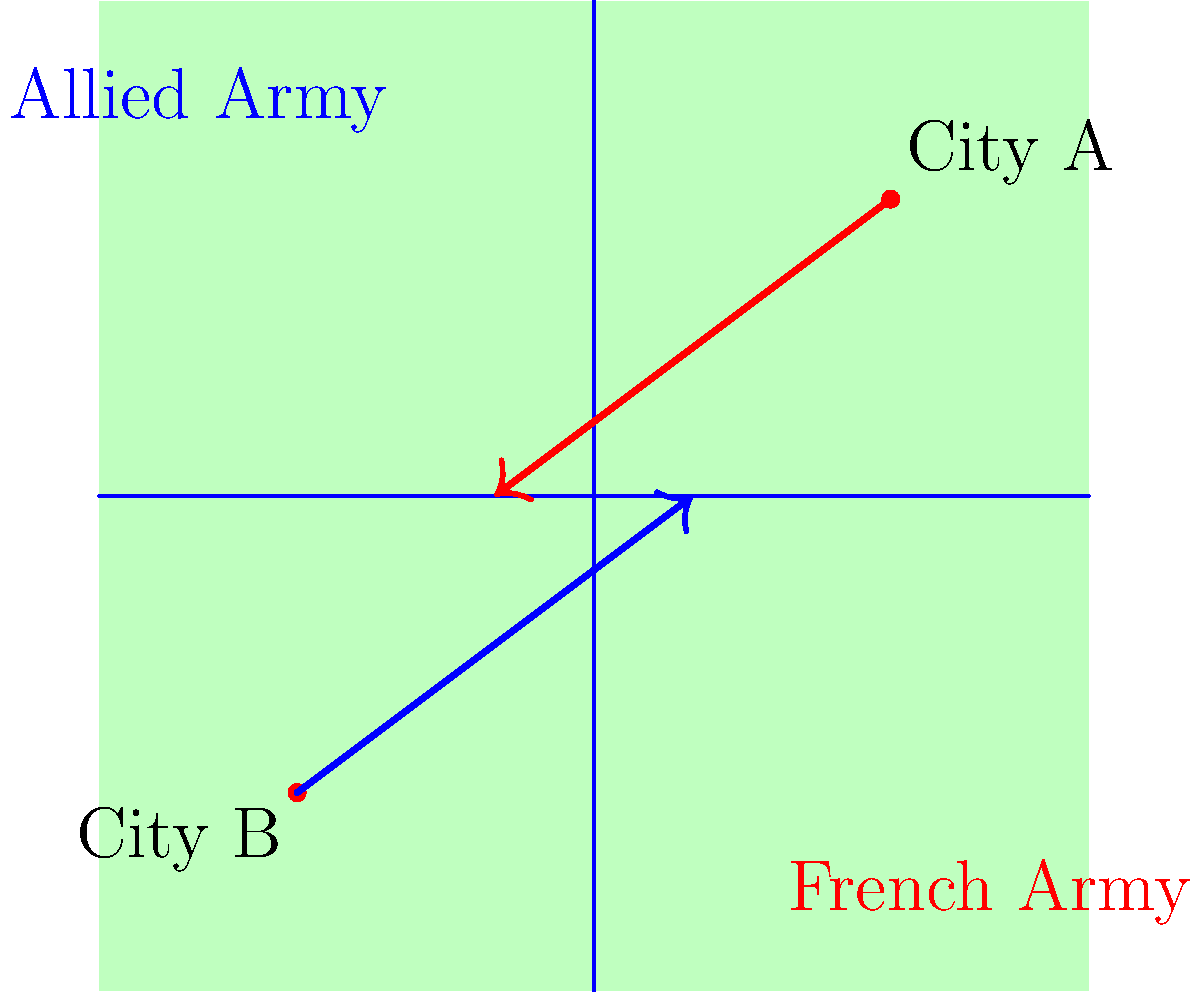Based on the map diagram, which strategic advantage would the French Army (red) likely have over the Allied Army (blue) in their approach to the central crossroads? To determine the strategic advantage of the French Army, let's analyze the troop movements and geographical features:

1. River system: The map shows two rivers intersecting at the center, forming a crossroads.

2. Troop positions:
   - The French Army (red) is moving from City A in the northeast.
   - The Allied Army (blue) is moving from City B in the southwest.

3. Approach to the crossroads:
   - The French Army can reach the crossroads without crossing any rivers.
   - The Allied Army must cross at least one river to reach the crossroads.

4. Military tactics in the Napoleonic era:
   - River crossings were often vulnerable points for armies.
   - Defending a river line was generally easier than forcing a crossing.

5. Strategic implications:
   - The French Army can arrive at the crossroads unimpeded by natural obstacles.
   - They can set up defensive positions along the river, forcing the Allied Army to cross under fire.
   - This gives the French Army control over the timing of the engagement.

Therefore, the French Army's strategic advantage is the ability to reach the crucial crossroads without crossing a river, while being able to contest the Allied Army's river crossing.
Answer: Unobstructed approach to the crossroads 